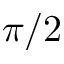Convert formula to latex. <formula><loc_0><loc_0><loc_500><loc_500>\pi / 2</formula> 